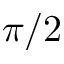Convert formula to latex. <formula><loc_0><loc_0><loc_500><loc_500>\pi / 2</formula> 